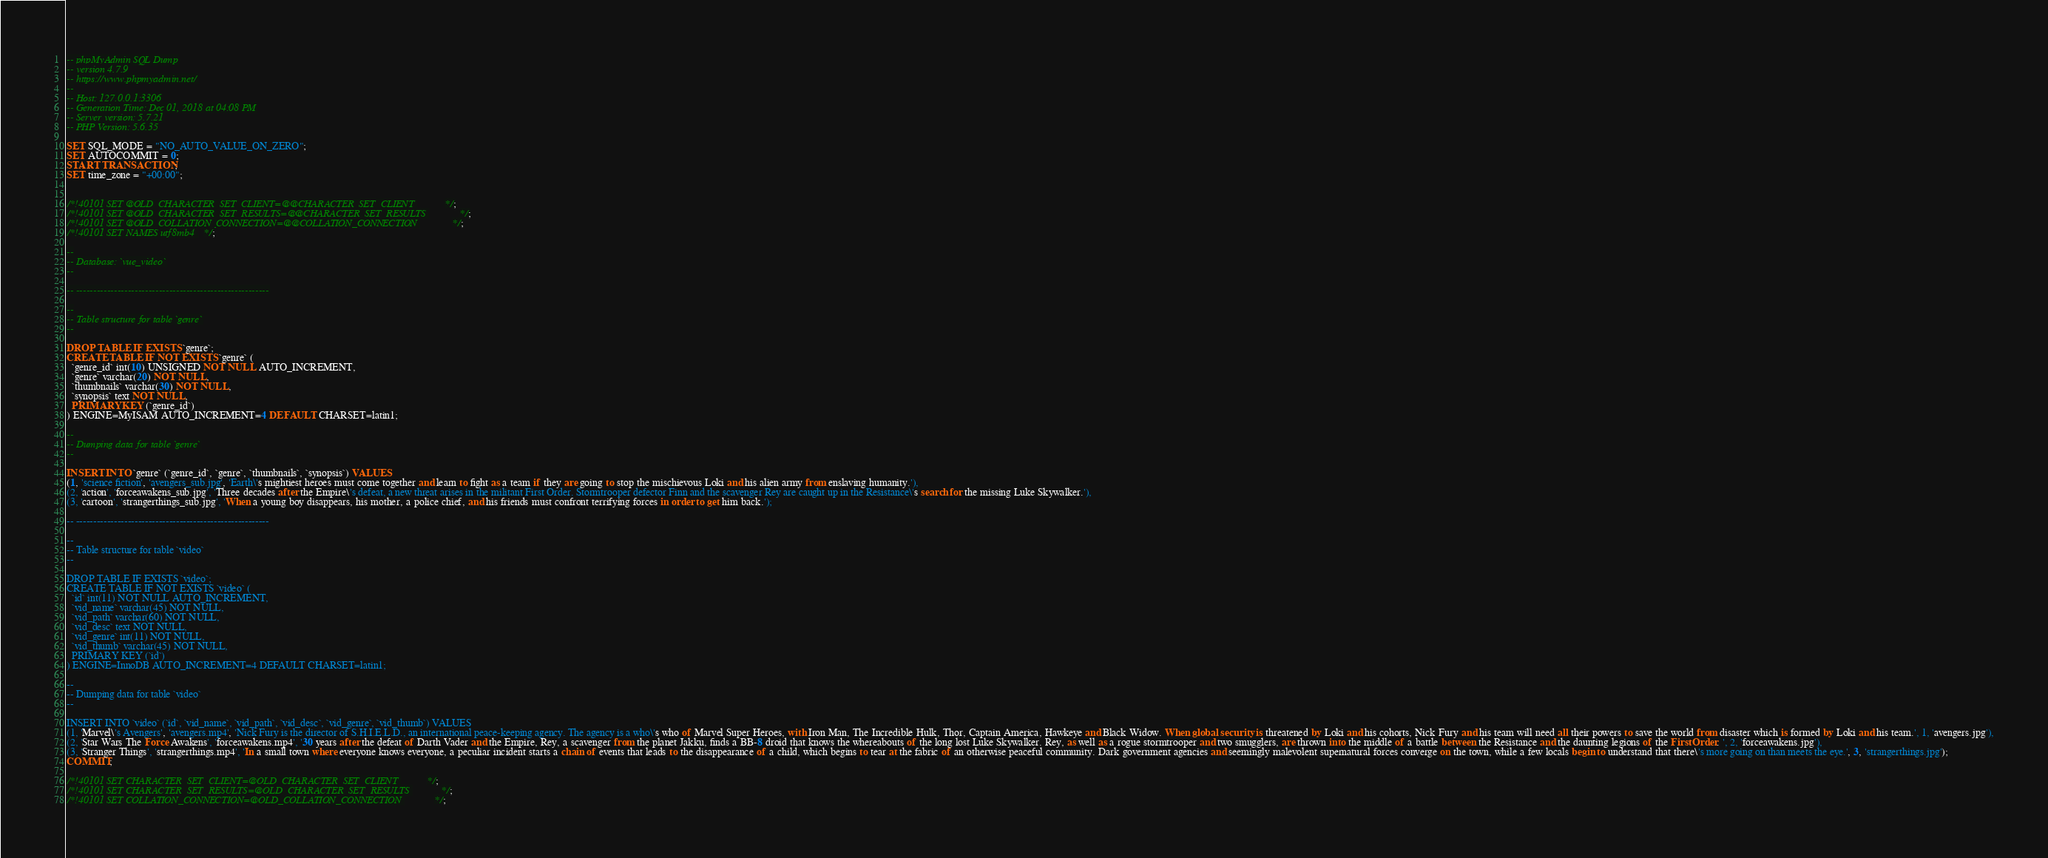<code> <loc_0><loc_0><loc_500><loc_500><_SQL_>-- phpMyAdmin SQL Dump
-- version 4.7.9
-- https://www.phpmyadmin.net/
--
-- Host: 127.0.0.1:3306
-- Generation Time: Dec 01, 2018 at 04:08 PM
-- Server version: 5.7.21
-- PHP Version: 5.6.35

SET SQL_MODE = "NO_AUTO_VALUE_ON_ZERO";
SET AUTOCOMMIT = 0;
START TRANSACTION;
SET time_zone = "+00:00";


/*!40101 SET @OLD_CHARACTER_SET_CLIENT=@@CHARACTER_SET_CLIENT */;
/*!40101 SET @OLD_CHARACTER_SET_RESULTS=@@CHARACTER_SET_RESULTS */;
/*!40101 SET @OLD_COLLATION_CONNECTION=@@COLLATION_CONNECTION */;
/*!40101 SET NAMES utf8mb4 */;

--
-- Database: `vue_video`
--

-- --------------------------------------------------------

--
-- Table structure for table `genre`
--

DROP TABLE IF EXISTS `genre`;
CREATE TABLE IF NOT EXISTS `genre` (
  `genre_id` int(10) UNSIGNED NOT NULL AUTO_INCREMENT,
  `genre` varchar(20) NOT NULL,
  `thumbnails` varchar(30) NOT NULL,
  `synopsis` text NOT NULL,
  PRIMARY KEY (`genre_id`)
) ENGINE=MyISAM AUTO_INCREMENT=4 DEFAULT CHARSET=latin1;

--
-- Dumping data for table `genre`
--

INSERT INTO `genre` (`genre_id`, `genre`, `thumbnails`, `synopsis`) VALUES
(1, 'science fiction', 'avengers_sub.jpg', 'Earth\'s mightiest heroes must come together and learn to fight as a team if they are going to stop the mischievous Loki and his alien army from enslaving humanity.'),
(2, 'action', 'forceawakens_sub.jpg', 'Three decades after the Empire\'s defeat, a new threat arises in the militant First Order. Stormtrooper defector Finn and the scavenger Rey are caught up in the Resistance\'s search for the missing Luke Skywalker.'),
(3, 'cartoon', 'strangerthings_sub.jpg', 'When a young boy disappears, his mother, a police chief, and his friends must confront terrifying forces in order to get him back.');

-- --------------------------------------------------------

--
-- Table structure for table `video`
--

DROP TABLE IF EXISTS `video`;
CREATE TABLE IF NOT EXISTS `video` (
  `id` int(11) NOT NULL AUTO_INCREMENT,
  `vid_name` varchar(45) NOT NULL,
  `vid_path` varchar(60) NOT NULL,
  `vid_desc` text NOT NULL,
  `vid_genre` int(11) NOT NULL,
  `vid_thumb` varchar(45) NOT NULL,
  PRIMARY KEY (`id`)
) ENGINE=InnoDB AUTO_INCREMENT=4 DEFAULT CHARSET=latin1;

--
-- Dumping data for table `video`
--

INSERT INTO `video` (`id`, `vid_name`, `vid_path`, `vid_desc`, `vid_genre`, `vid_thumb`) VALUES
(1, 'Marvel\'s Avengers', 'avengers.mp4', 'Nick Fury is the director of S.H.I.E.L.D., an international peace-keeping agency. The agency is a who\'s who of Marvel Super Heroes, with Iron Man, The Incredible Hulk, Thor, Captain America, Hawkeye and Black Widow. When global security is threatened by Loki and his cohorts, Nick Fury and his team will need all their powers to save the world from disaster which is formed by Loki and his team.', 1, 'avengers.jpg'),
(2, 'Star Wars The Force Awakens', 'forceawakens.mp4', '30 years after the defeat of Darth Vader and the Empire, Rey, a scavenger from the planet Jakku, finds a BB-8 droid that knows the whereabouts of the long lost Luke Skywalker. Rey, as well as a rogue stormtrooper and two smugglers, are thrown into the middle of a battle between the Resistance and the daunting legions of the First Order. ', 2, 'forceawakens.jpg'),
(3, 'Stranger Things', 'strangerthings.mp4', 'In a small town where everyone knows everyone, a peculiar incident starts a chain of events that leads to the disappearance of a child, which begins to tear at the fabric of an otherwise peaceful community. Dark government agencies and seemingly malevolent supernatural forces converge on the town, while a few locals begin to understand that there\'s more going on than meets the eye.', 3, 'strangerthings.jpg');
COMMIT;

/*!40101 SET CHARACTER_SET_CLIENT=@OLD_CHARACTER_SET_CLIENT */;
/*!40101 SET CHARACTER_SET_RESULTS=@OLD_CHARACTER_SET_RESULTS */;
/*!40101 SET COLLATION_CONNECTION=@OLD_COLLATION_CONNECTION */;
</code> 